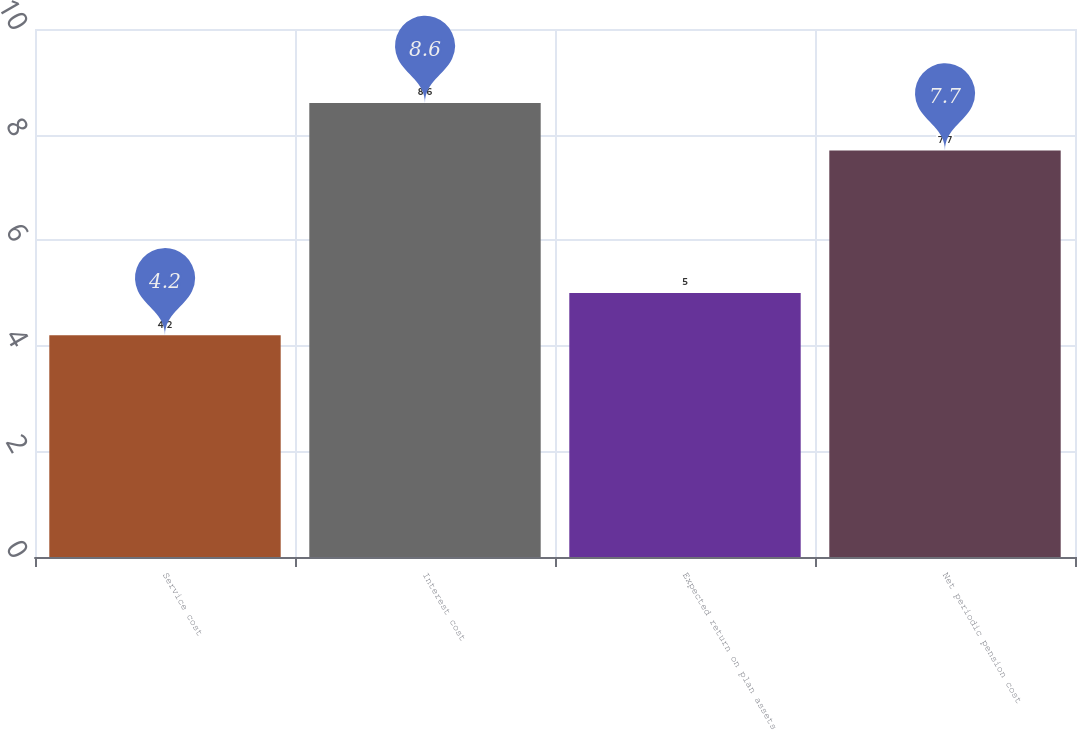Convert chart to OTSL. <chart><loc_0><loc_0><loc_500><loc_500><bar_chart><fcel>Service cost<fcel>Interest cost<fcel>Expected return on plan assets<fcel>Net periodic pension cost<nl><fcel>4.2<fcel>8.6<fcel>5<fcel>7.7<nl></chart> 